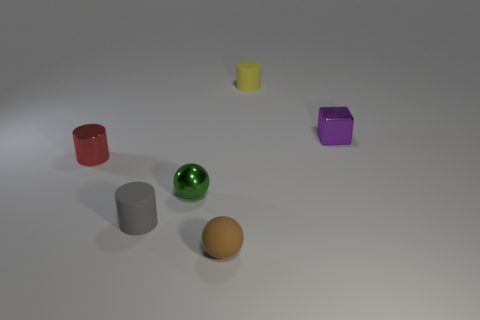Add 4 small brown balls. How many objects exist? 10 Subtract all spheres. How many objects are left? 4 Add 3 big green metallic things. How many big green metallic things exist? 3 Subtract 0 purple cylinders. How many objects are left? 6 Subtract all small brown balls. Subtract all yellow things. How many objects are left? 4 Add 5 tiny green spheres. How many tiny green spheres are left? 6 